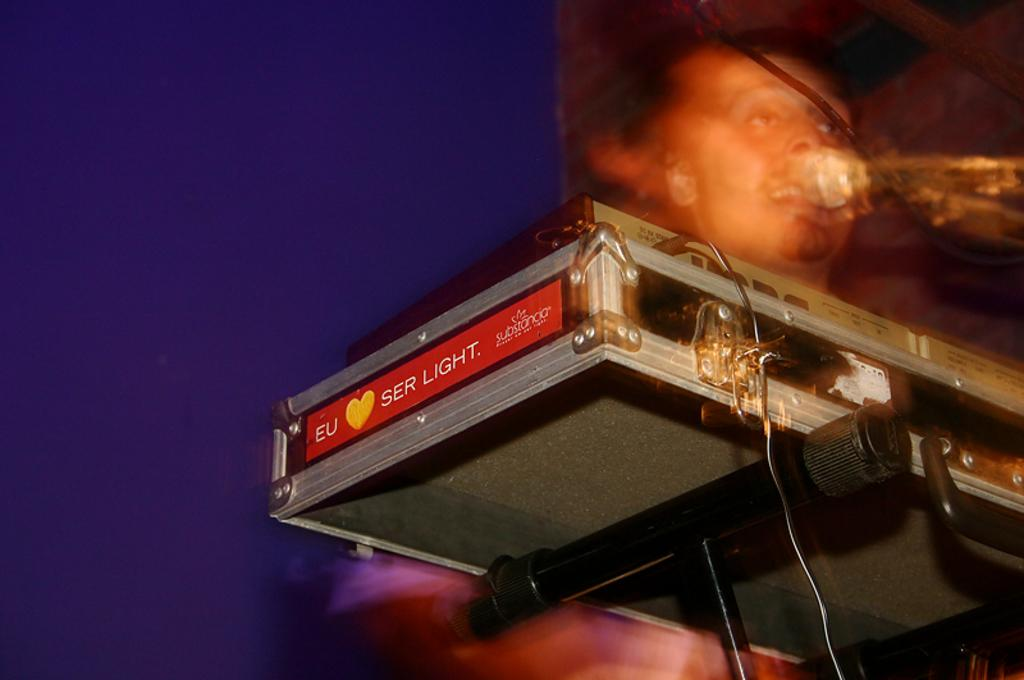What can be seen in the image related to technology? There is a device and a cable in the image. What is the person in the image holding? The person in the image is holding a mic. Can you describe the background of the image? The background of the image has a violet color. What other objects are present in the image? There are some objects in the image, but their specific details are not mentioned in the facts. Is there a system of water flowing in the image? There is no mention of water or any water system in the image. Can you see a banana in the image? There is no banana present in the image. 